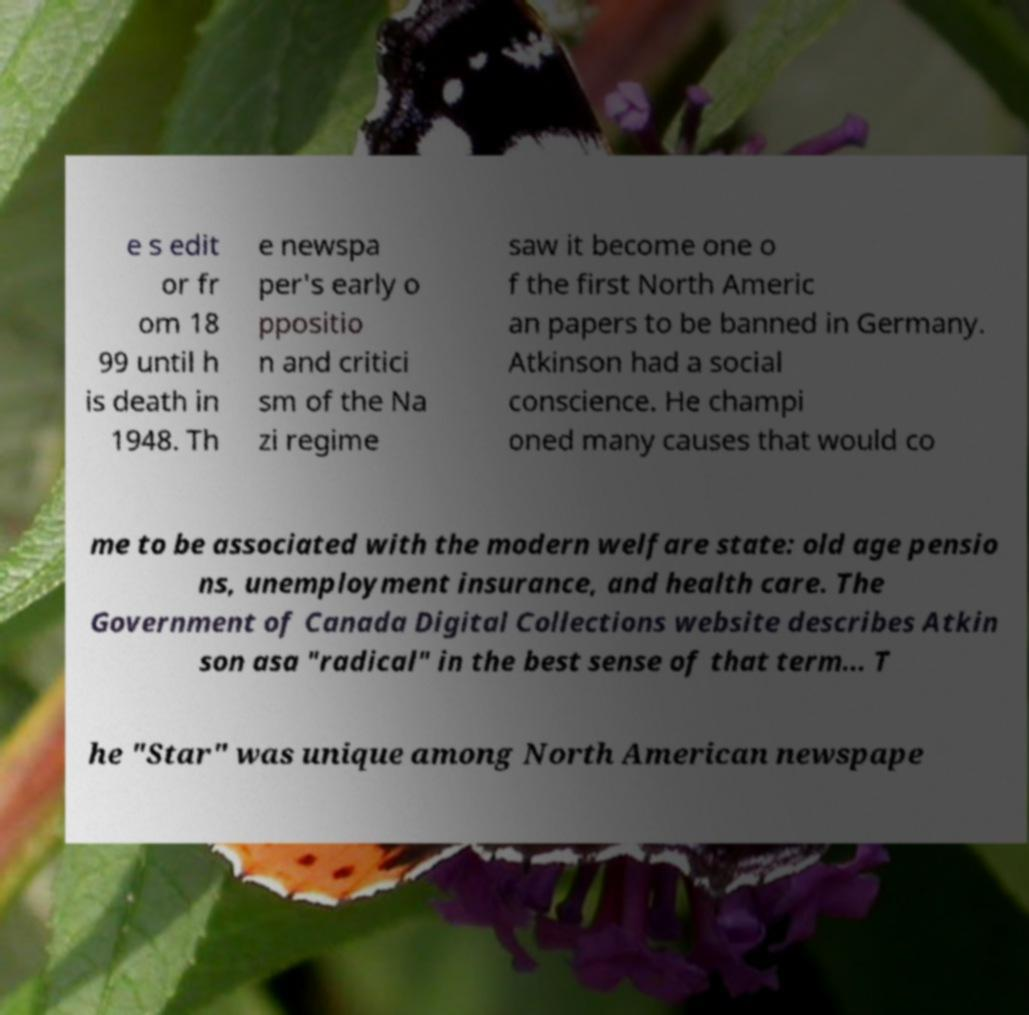For documentation purposes, I need the text within this image transcribed. Could you provide that? e s edit or fr om 18 99 until h is death in 1948. Th e newspa per's early o ppositio n and critici sm of the Na zi regime saw it become one o f the first North Americ an papers to be banned in Germany. Atkinson had a social conscience. He champi oned many causes that would co me to be associated with the modern welfare state: old age pensio ns, unemployment insurance, and health care. The Government of Canada Digital Collections website describes Atkin son asa "radical" in the best sense of that term... T he "Star" was unique among North American newspape 